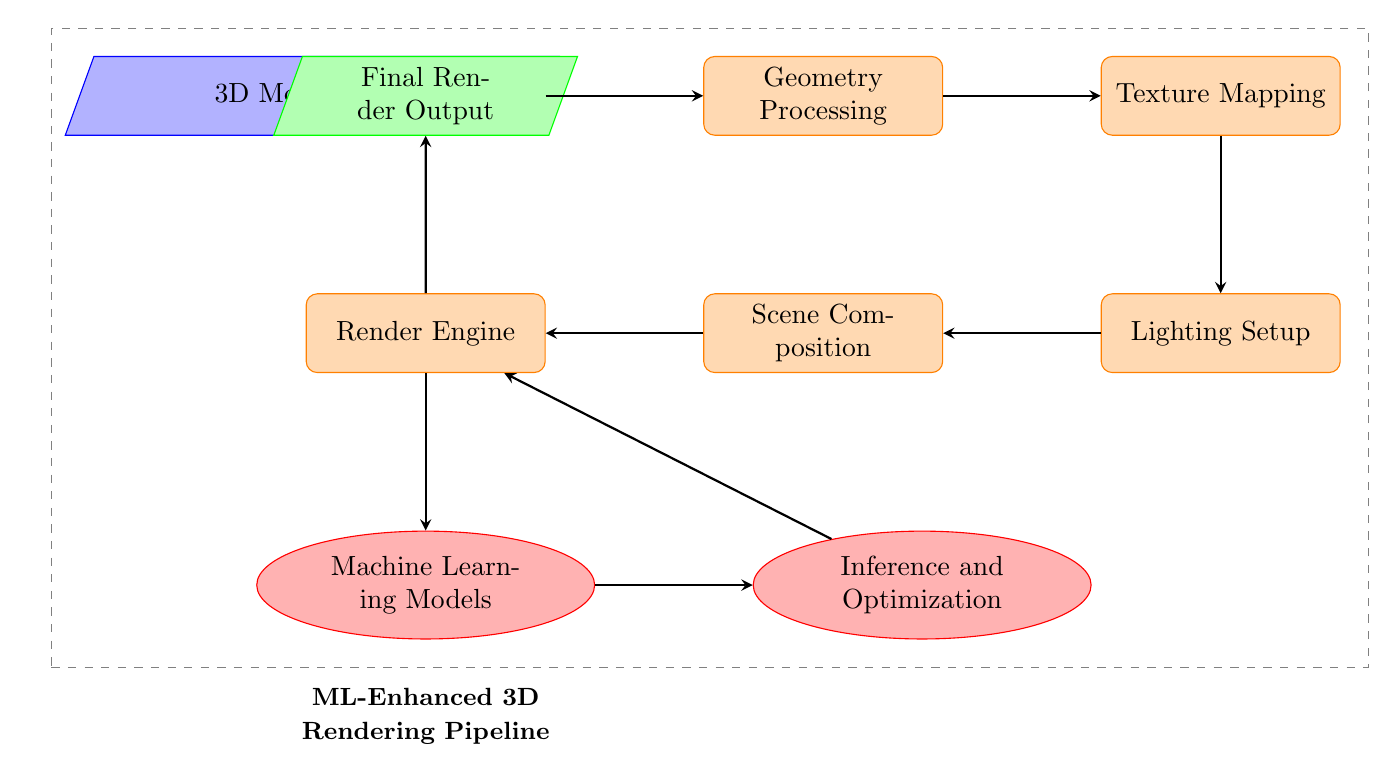What is the first step in the workflow? The diagram shows that the first step is depicted by the "3D Model Input" node, which is highlighted as the entry point of the workflow.
Answer: 3D Model Input How many processes are involved in the pipeline? The diagram has five process nodes: "Geometry Processing," "Texture Mapping," "Lighting Setup," "Scene Composition," and "Render Engine." Counting these gives us a total of five processes.
Answer: 5 Which node is directly connected to the "Render Engine"? The arrow indicates that the "Machine Learning Models" node is directly below the "Render Engine" node, showing the direct connection between these two.
Answer: Machine Learning Models What type of models are used to enhance the rendering pipeline? The node labeled "Machine Learning Models" indicates that machine learning techniques/formulations are being applied for optimization within the rendering pipeline.
Answer: Machine Learning Models Which node is optimized by inference after it receives the output from the machine learning models? The diagram shows that the output from the "Inference and Optimization" node is directed back to the "Render Engine," indicating it is the node being optimized.
Answer: Render Engine How does the "Final Render Output" relate to the workflow? The "Final Render Output" is at the top of the diagram and receives input from the "Render Engine," indicating it is the end product of the entire rendering process.
Answer: Final Render Output What is the relationship between "Lighting Setup" and "Scene Composition"? The diagram shows a direct left-side connection from "Lighting Setup" to "Scene Composition," indicating that "Lighting Setup" occurs before "Scene Composition" in the workflow.
Answer: Directly connected In which part of the pipeline does optimization occur? The optimization occurs in the "Inference and Optimization" node, as indicated by its placement following "Machine Learning Models" and preceding the return to "Render Engine."
Answer: Inference and Optimization What does the dashed box surrounding the nodes indicate? The dashed box encompasses all the nodes in the diagram, suggesting that these nodes represent the overall process flow of the optimized 3D rendering pipeline.
Answer: Overall process flow 